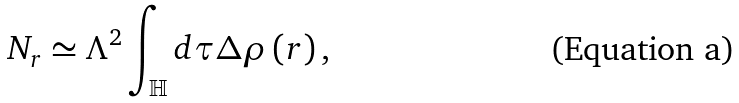<formula> <loc_0><loc_0><loc_500><loc_500>N _ { r } \simeq \Lambda ^ { 2 } \int _ { \mathbb { H } } d \tau \Delta \rho \left ( r \right ) ,</formula> 